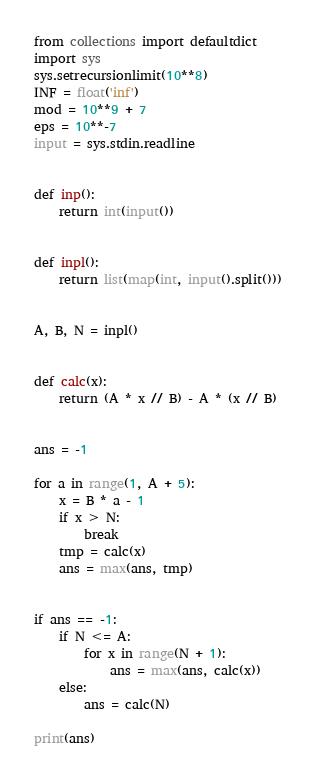<code> <loc_0><loc_0><loc_500><loc_500><_Python_>from collections import defaultdict
import sys
sys.setrecursionlimit(10**8)
INF = float('inf')
mod = 10**9 + 7
eps = 10**-7
input = sys.stdin.readline


def inp():
    return int(input())


def inpl():
    return list(map(int, input().split()))


A, B, N = inpl()


def calc(x):
    return (A * x // B) - A * (x // B)


ans = -1

for a in range(1, A + 5):
    x = B * a - 1
    if x > N:
        break
    tmp = calc(x)
    ans = max(ans, tmp)


if ans == -1:
    if N <= A:
        for x in range(N + 1):
            ans = max(ans, calc(x))
    else:
        ans = calc(N)

print(ans)
</code> 